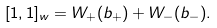Convert formula to latex. <formula><loc_0><loc_0><loc_500><loc_500>[ 1 , 1 ] _ { w } = W _ { + } ( b _ { + } ) + W _ { - } ( b _ { - } ) .</formula> 